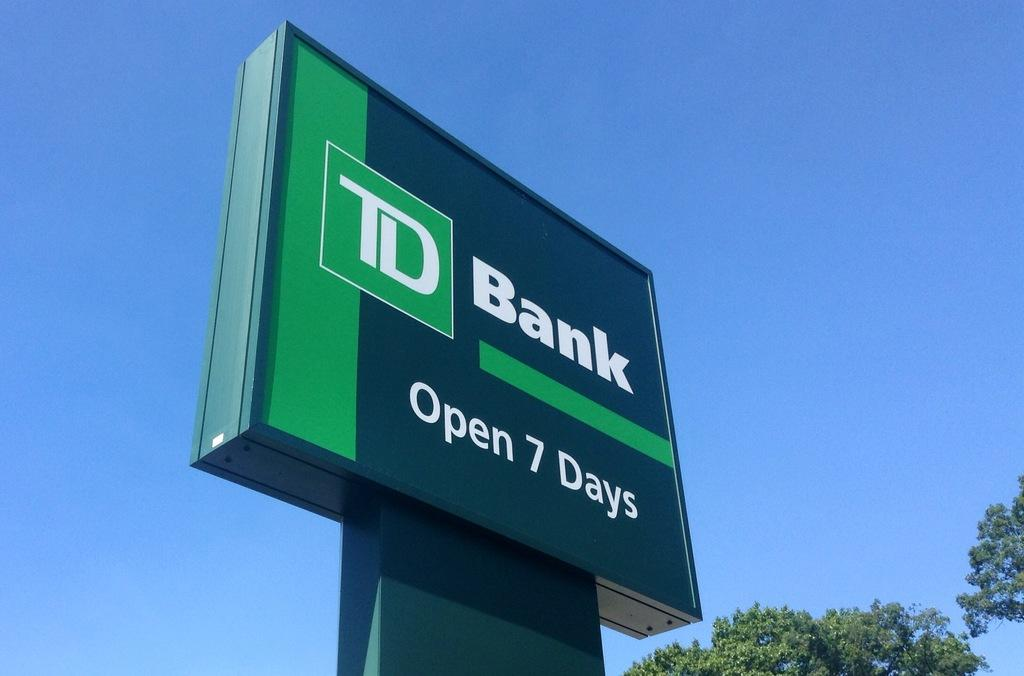Provide a one-sentence caption for the provided image. The hours of operation at TD Bank span all seven days of the week. 